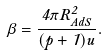<formula> <loc_0><loc_0><loc_500><loc_500>\beta = \frac { 4 \pi R _ { A d S } ^ { 2 } } { ( p + 1 ) u _ { \Lambda } } .</formula> 